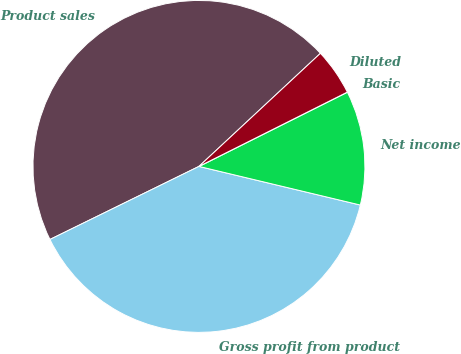Convert chart to OTSL. <chart><loc_0><loc_0><loc_500><loc_500><pie_chart><fcel>Product sales<fcel>Gross profit from product<fcel>Net income<fcel>Basic<fcel>Diluted<nl><fcel>45.32%<fcel>39.0%<fcel>11.12%<fcel>0.01%<fcel>4.54%<nl></chart> 